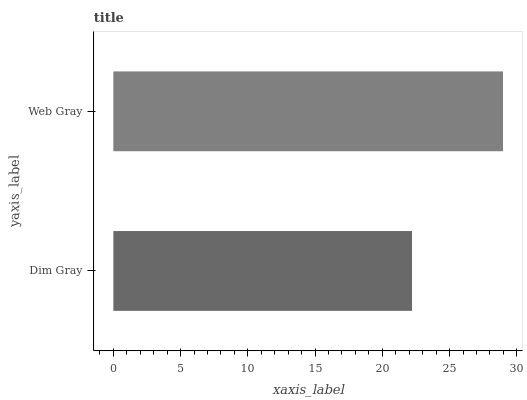Is Dim Gray the minimum?
Answer yes or no. Yes. Is Web Gray the maximum?
Answer yes or no. Yes. Is Web Gray the minimum?
Answer yes or no. No. Is Web Gray greater than Dim Gray?
Answer yes or no. Yes. Is Dim Gray less than Web Gray?
Answer yes or no. Yes. Is Dim Gray greater than Web Gray?
Answer yes or no. No. Is Web Gray less than Dim Gray?
Answer yes or no. No. Is Web Gray the high median?
Answer yes or no. Yes. Is Dim Gray the low median?
Answer yes or no. Yes. Is Dim Gray the high median?
Answer yes or no. No. Is Web Gray the low median?
Answer yes or no. No. 